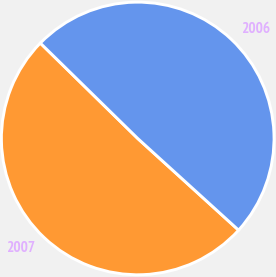Convert chart to OTSL. <chart><loc_0><loc_0><loc_500><loc_500><pie_chart><fcel>2007<fcel>2006<nl><fcel>50.59%<fcel>49.41%<nl></chart> 